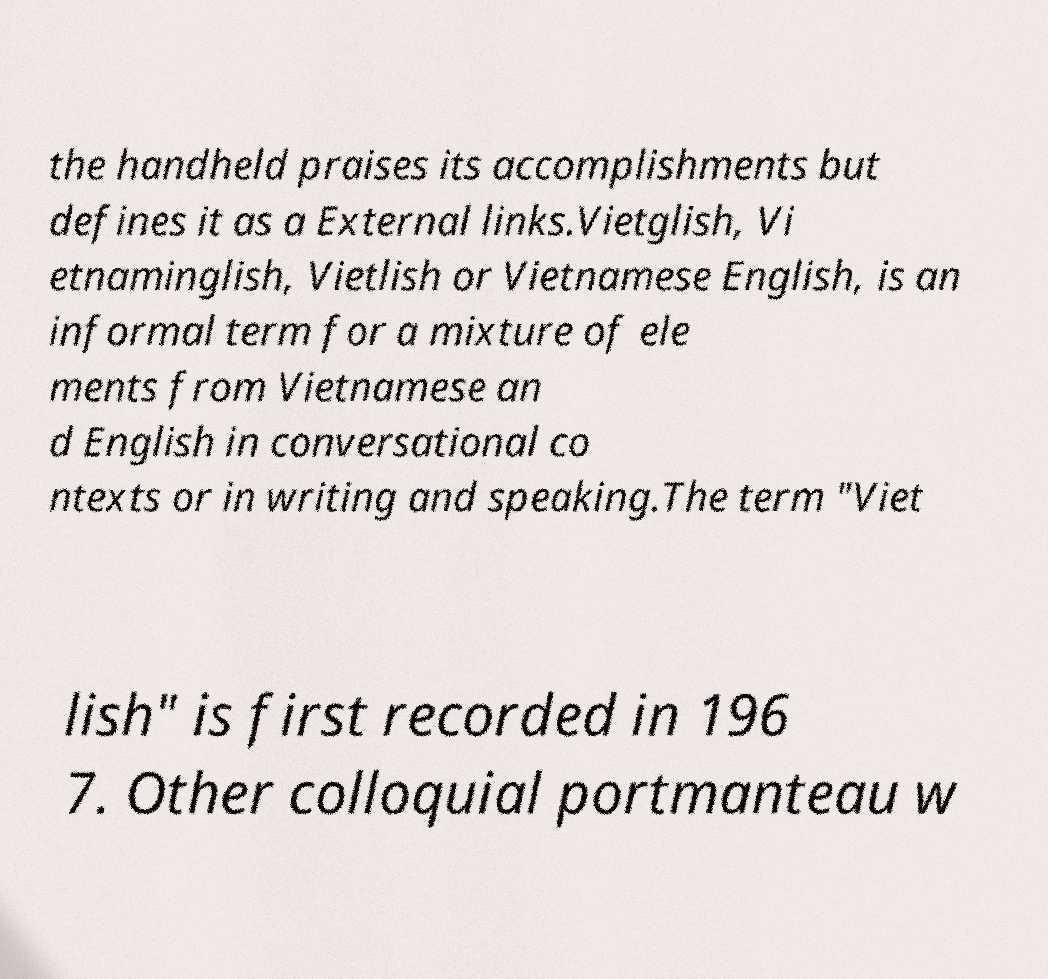Please read and relay the text visible in this image. What does it say? the handheld praises its accomplishments but defines it as a External links.Vietglish, Vi etnaminglish, Vietlish or Vietnamese English, is an informal term for a mixture of ele ments from Vietnamese an d English in conversational co ntexts or in writing and speaking.The term "Viet lish" is first recorded in 196 7. Other colloquial portmanteau w 